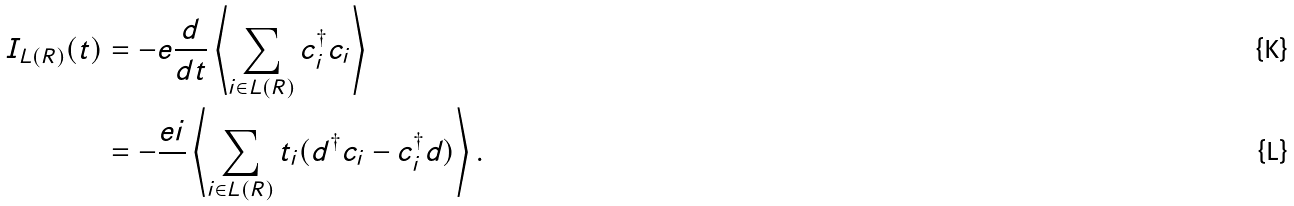Convert formula to latex. <formula><loc_0><loc_0><loc_500><loc_500>I _ { L ( R ) } ( t ) & = - e \frac { d } { d t } \left \langle \sum _ { i \in L ( R ) } c _ { i } ^ { \dagger } c _ { i } \right \rangle \\ & = - \frac { e i } { } \left \langle \sum _ { i \in L ( R ) } t _ { i } ( d ^ { \dagger } c _ { i } - c _ { i } ^ { \dagger } d ) \right \rangle .</formula> 